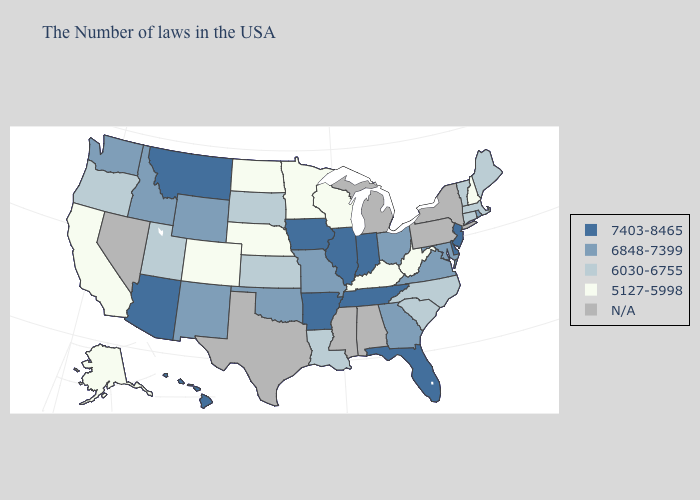Does the map have missing data?
Concise answer only. Yes. What is the value of Wisconsin?
Write a very short answer. 5127-5998. What is the value of Georgia?
Quick response, please. 6848-7399. Does Ohio have the lowest value in the USA?
Answer briefly. No. Among the states that border New Mexico , which have the lowest value?
Answer briefly. Colorado. Name the states that have a value in the range 6848-7399?
Short answer required. Rhode Island, Maryland, Virginia, Ohio, Georgia, Missouri, Oklahoma, Wyoming, New Mexico, Idaho, Washington. What is the value of Washington?
Give a very brief answer. 6848-7399. What is the highest value in states that border Virginia?
Keep it brief. 7403-8465. Does the map have missing data?
Short answer required. Yes. What is the value of Vermont?
Concise answer only. 6030-6755. Does Oregon have the highest value in the West?
Keep it brief. No. Which states have the lowest value in the USA?
Short answer required. New Hampshire, West Virginia, Kentucky, Wisconsin, Minnesota, Nebraska, North Dakota, Colorado, California, Alaska. What is the value of Washington?
Keep it brief. 6848-7399. What is the value of Iowa?
Be succinct. 7403-8465. 